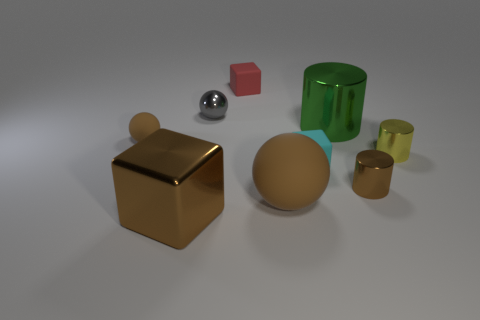Subtract all small cubes. How many cubes are left? 1 Subtract all spheres. How many objects are left? 6 Subtract 1 cubes. How many cubes are left? 2 Add 1 large green metal objects. How many objects exist? 10 Subtract all brown balls. How many balls are left? 1 Subtract 0 purple cylinders. How many objects are left? 9 Subtract all purple cylinders. Subtract all red cubes. How many cylinders are left? 3 Subtract all purple blocks. How many green balls are left? 0 Subtract all gray shiny spheres. Subtract all large things. How many objects are left? 5 Add 6 small red blocks. How many small red blocks are left? 7 